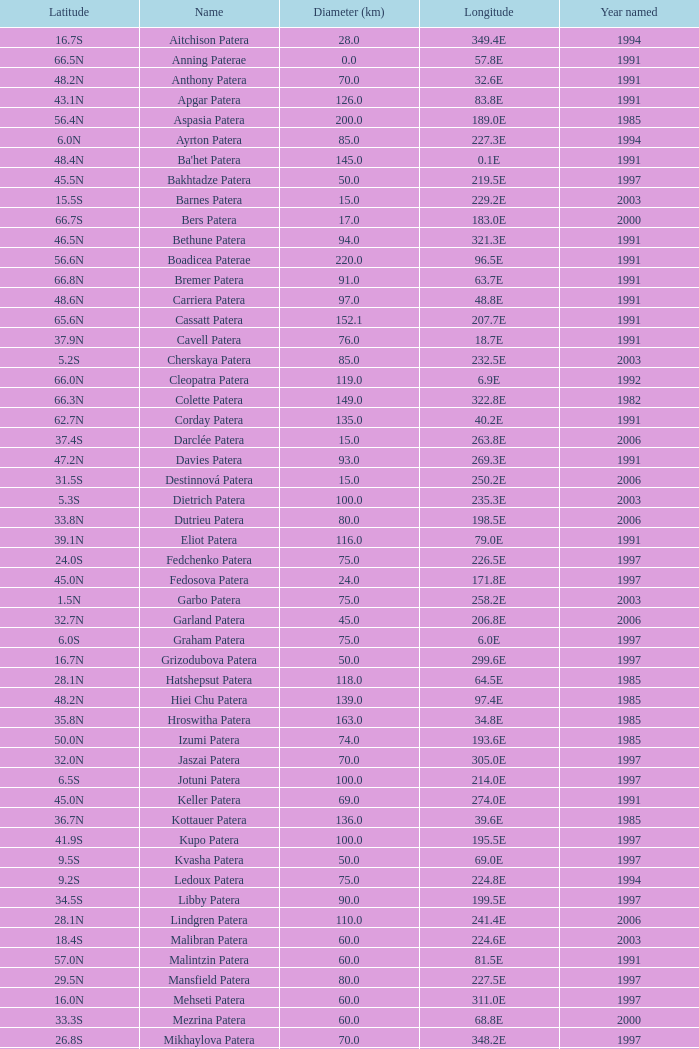What is Year Named, when Longitude is 227.5E? 1997.0. 